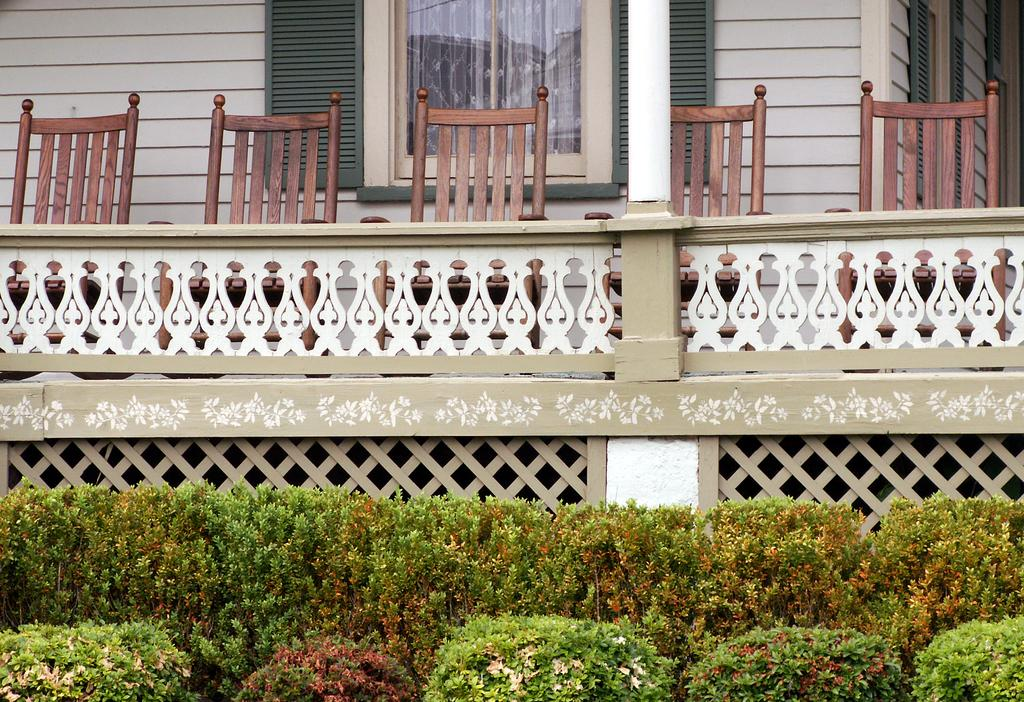What type of furniture is present in the image? There are chairs in the image. What color are the chairs? The chairs are brown in color. What type of structure is visible in the image? There is a building in the image. What color is the building? The building is white in color. What architectural feature can be seen in the image? There is a window in the image. What type of vegetation is present in the image? There are plants in the image. What color are the plants? A: The plants are green in color. Can you tell me the current status of the receipt in the image? There is no receipt present in the image. How many times do the plants turn around in the image? The plants do not turn around in the image; they are stationary. 